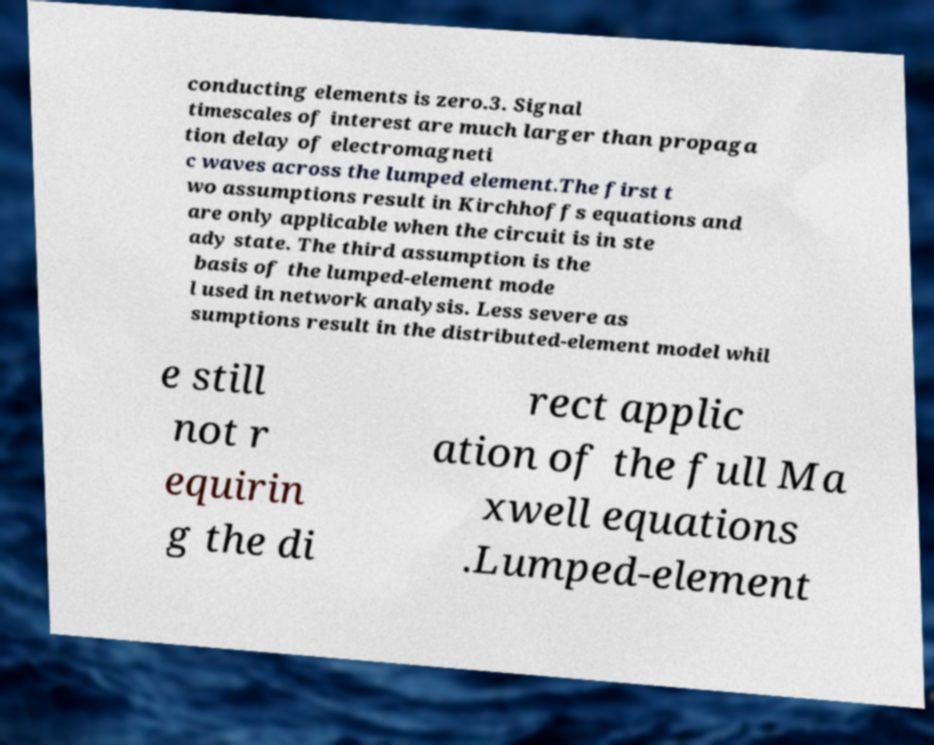For documentation purposes, I need the text within this image transcribed. Could you provide that? conducting elements is zero.3. Signal timescales of interest are much larger than propaga tion delay of electromagneti c waves across the lumped element.The first t wo assumptions result in Kirchhoffs equations and are only applicable when the circuit is in ste ady state. The third assumption is the basis of the lumped-element mode l used in network analysis. Less severe as sumptions result in the distributed-element model whil e still not r equirin g the di rect applic ation of the full Ma xwell equations .Lumped-element 